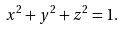<formula> <loc_0><loc_0><loc_500><loc_500>x ^ { 2 } + y ^ { 2 } + z ^ { 2 } = 1 .</formula> 